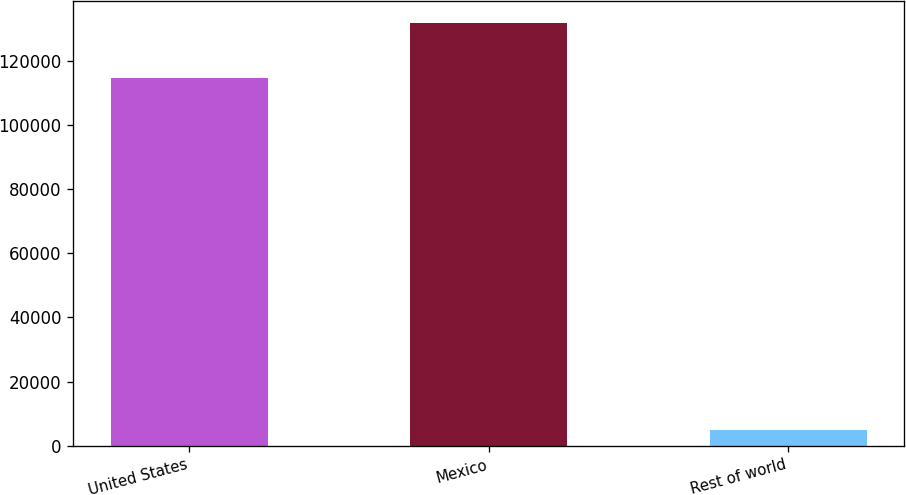Convert chart. <chart><loc_0><loc_0><loc_500><loc_500><bar_chart><fcel>United States<fcel>Mexico<fcel>Rest of world<nl><fcel>114492<fcel>131862<fcel>5011<nl></chart> 